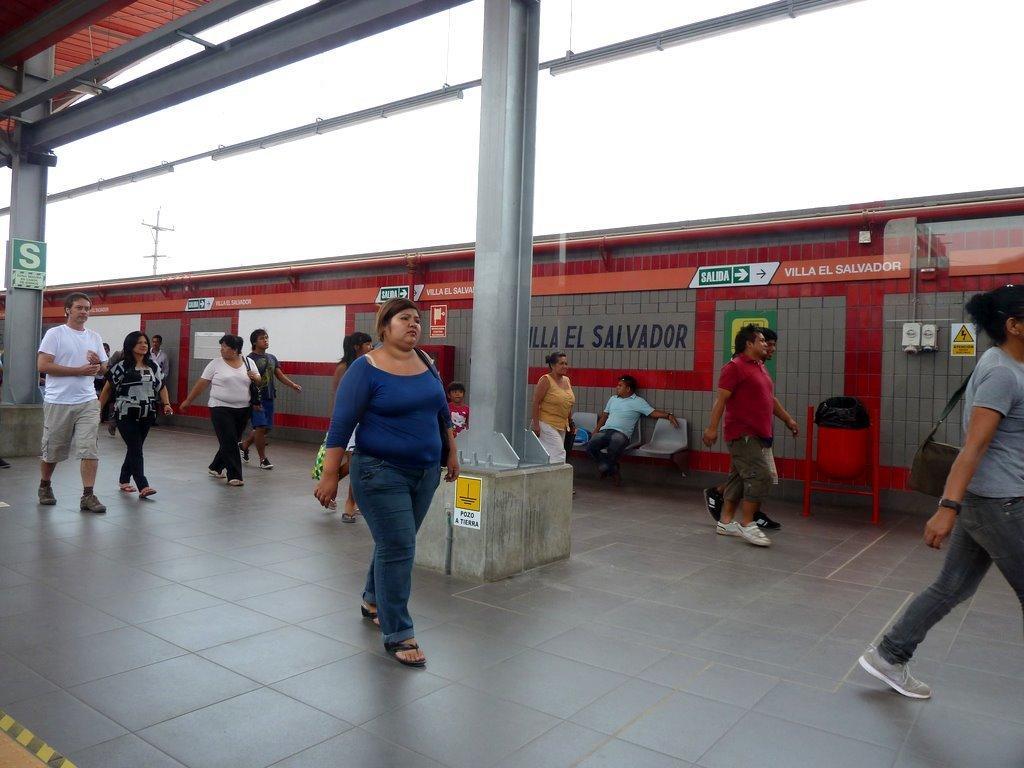How would you summarize this image in a sentence or two? In the middle a woman is walking on the floor she wore a blue color t-shirt, In the right side a man is sitting on the chair. Few other persons are walking on this floor. 